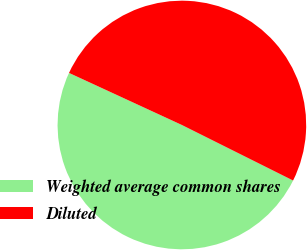Convert chart to OTSL. <chart><loc_0><loc_0><loc_500><loc_500><pie_chart><fcel>Weighted average common shares<fcel>Diluted<nl><fcel>49.51%<fcel>50.49%<nl></chart> 